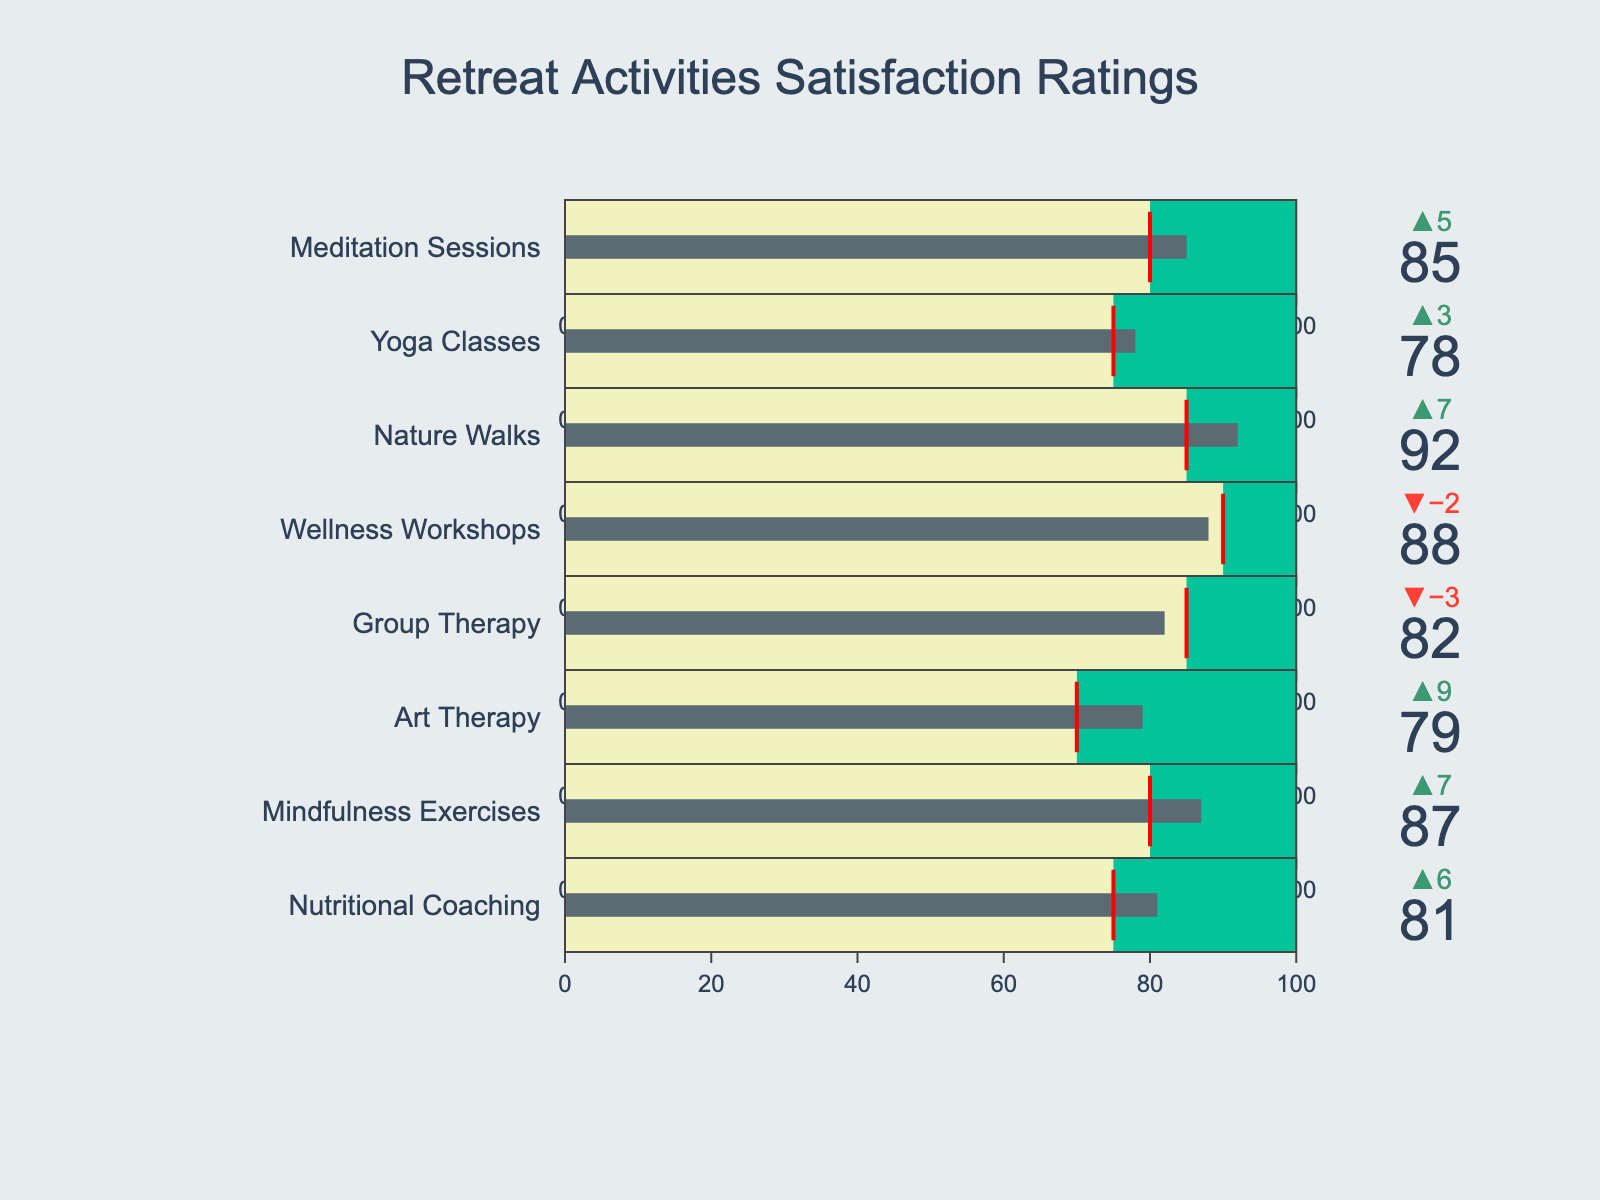What is the highest satisfaction rating among all activities? The highest satisfaction rating can be found by looking at the "Actual" values for each activity and identifying the maximum value. Meditation Sessions, Yoga Classes, Nature Walks, Wellness Workshops, Group Therapy, Art Therapy, Mindfulness Exercises, and Nutritional Coaching have the values 85, 78, 92, 88, 82, 79, 87, and 81 respectively. The highest is 92 from Nature Walks.
Answer: 92 Which activity has the highest target goal? To find the highest target goal, compare the "Target" values of all activities. Meditation Sessions, Yoga Classes, Nature Walks, Wellness Workshops, Group Therapy, Art Therapy, Mindfulness Exercises, and Nutritional Coaching have target values of 80, 75, 85, 90, 85, 70, 80, and 75, respectively. The highest is 90 from Wellness Workshops.
Answer: Wellness Workshops How many activities exceeded their target satisfaction rating? To determine the number of activities that exceeded their targets, compare the "Actual" values to the "Target" values for each of the eight activities. Meditation Sessions (85 vs 80), Yoga Classes (78 vs 75), Nature Walks (92 vs 85), Art Therapy (79 vs 70), Mindfulness Exercises (87 vs 80), and Nutritional Coaching (81 vs 75) exceeded their targets. Wellness Workshops (88 vs 90) and Group Therapy (82 vs 85) did not. Six activities exceeded their targets.
Answer: 6 Which activity fell short of its target satisfaction rating by the largest margin? To find the activity with the largest shortfall, compute the difference between "Target" and "Actual" for each activity that did not meet its target. Wellness Workshops fell short by 2 (90 - 88) and Group Therapy by 3 (85 - 82). The largest shortfall is Group Therapy.
Answer: Group Therapy Are there any activities where the actual satisfaction rating equals the target? Check if any "Actual" value is exactly equal to the corresponding "Target" value. Looking through all activities, none have an "Actual" satisfaction rating equal to their "Target".
Answer: No What is the average satisfaction rating (actual) of all activities? Add all the "Actual" satisfaction ratings and then divide by the number of activities: (85 + 78 + 92 + 88 + 82 + 79 + 87 + 81) / 8 = 672 / 8 = 84.
Answer: 84 Which activity has the lowest actual satisfaction rating? Find the lowest "Actual" value among the activities. The values are 85 (Meditation Sessions), 78 (Yoga Classes), 92 (Nature Walks), 88 (Wellness Workshops), 82 (Group Therapy), 79 (Art Therapy), 87 (Mindfulness Exercises), and 81 (Nutritional Coaching). The lowest is 78 for Yoga Classes.
Answer: Yoga Classes By how much did Art Therapy exceed its target satisfaction rating? Calculate the difference between the "Actual" and "Target" values for Art Therapy: 79 (Actual) - 70 (Target) = 9.
Answer: 9 What is the difference between the highest actual satisfaction rating and the lowest actual satisfaction rating? Identify the highest and lowest "Actual" values, then find their difference: Highest is 92 (Nature Walks) and lowest is 78 (Yoga Classes), so 92 - 78 = 14.
Answer: 14 